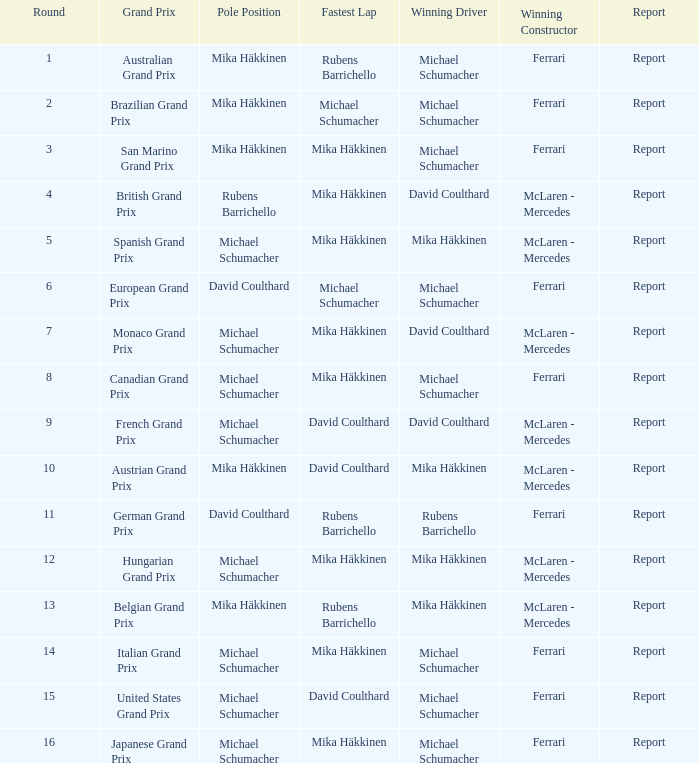What was the report of the Belgian Grand Prix? Report. 